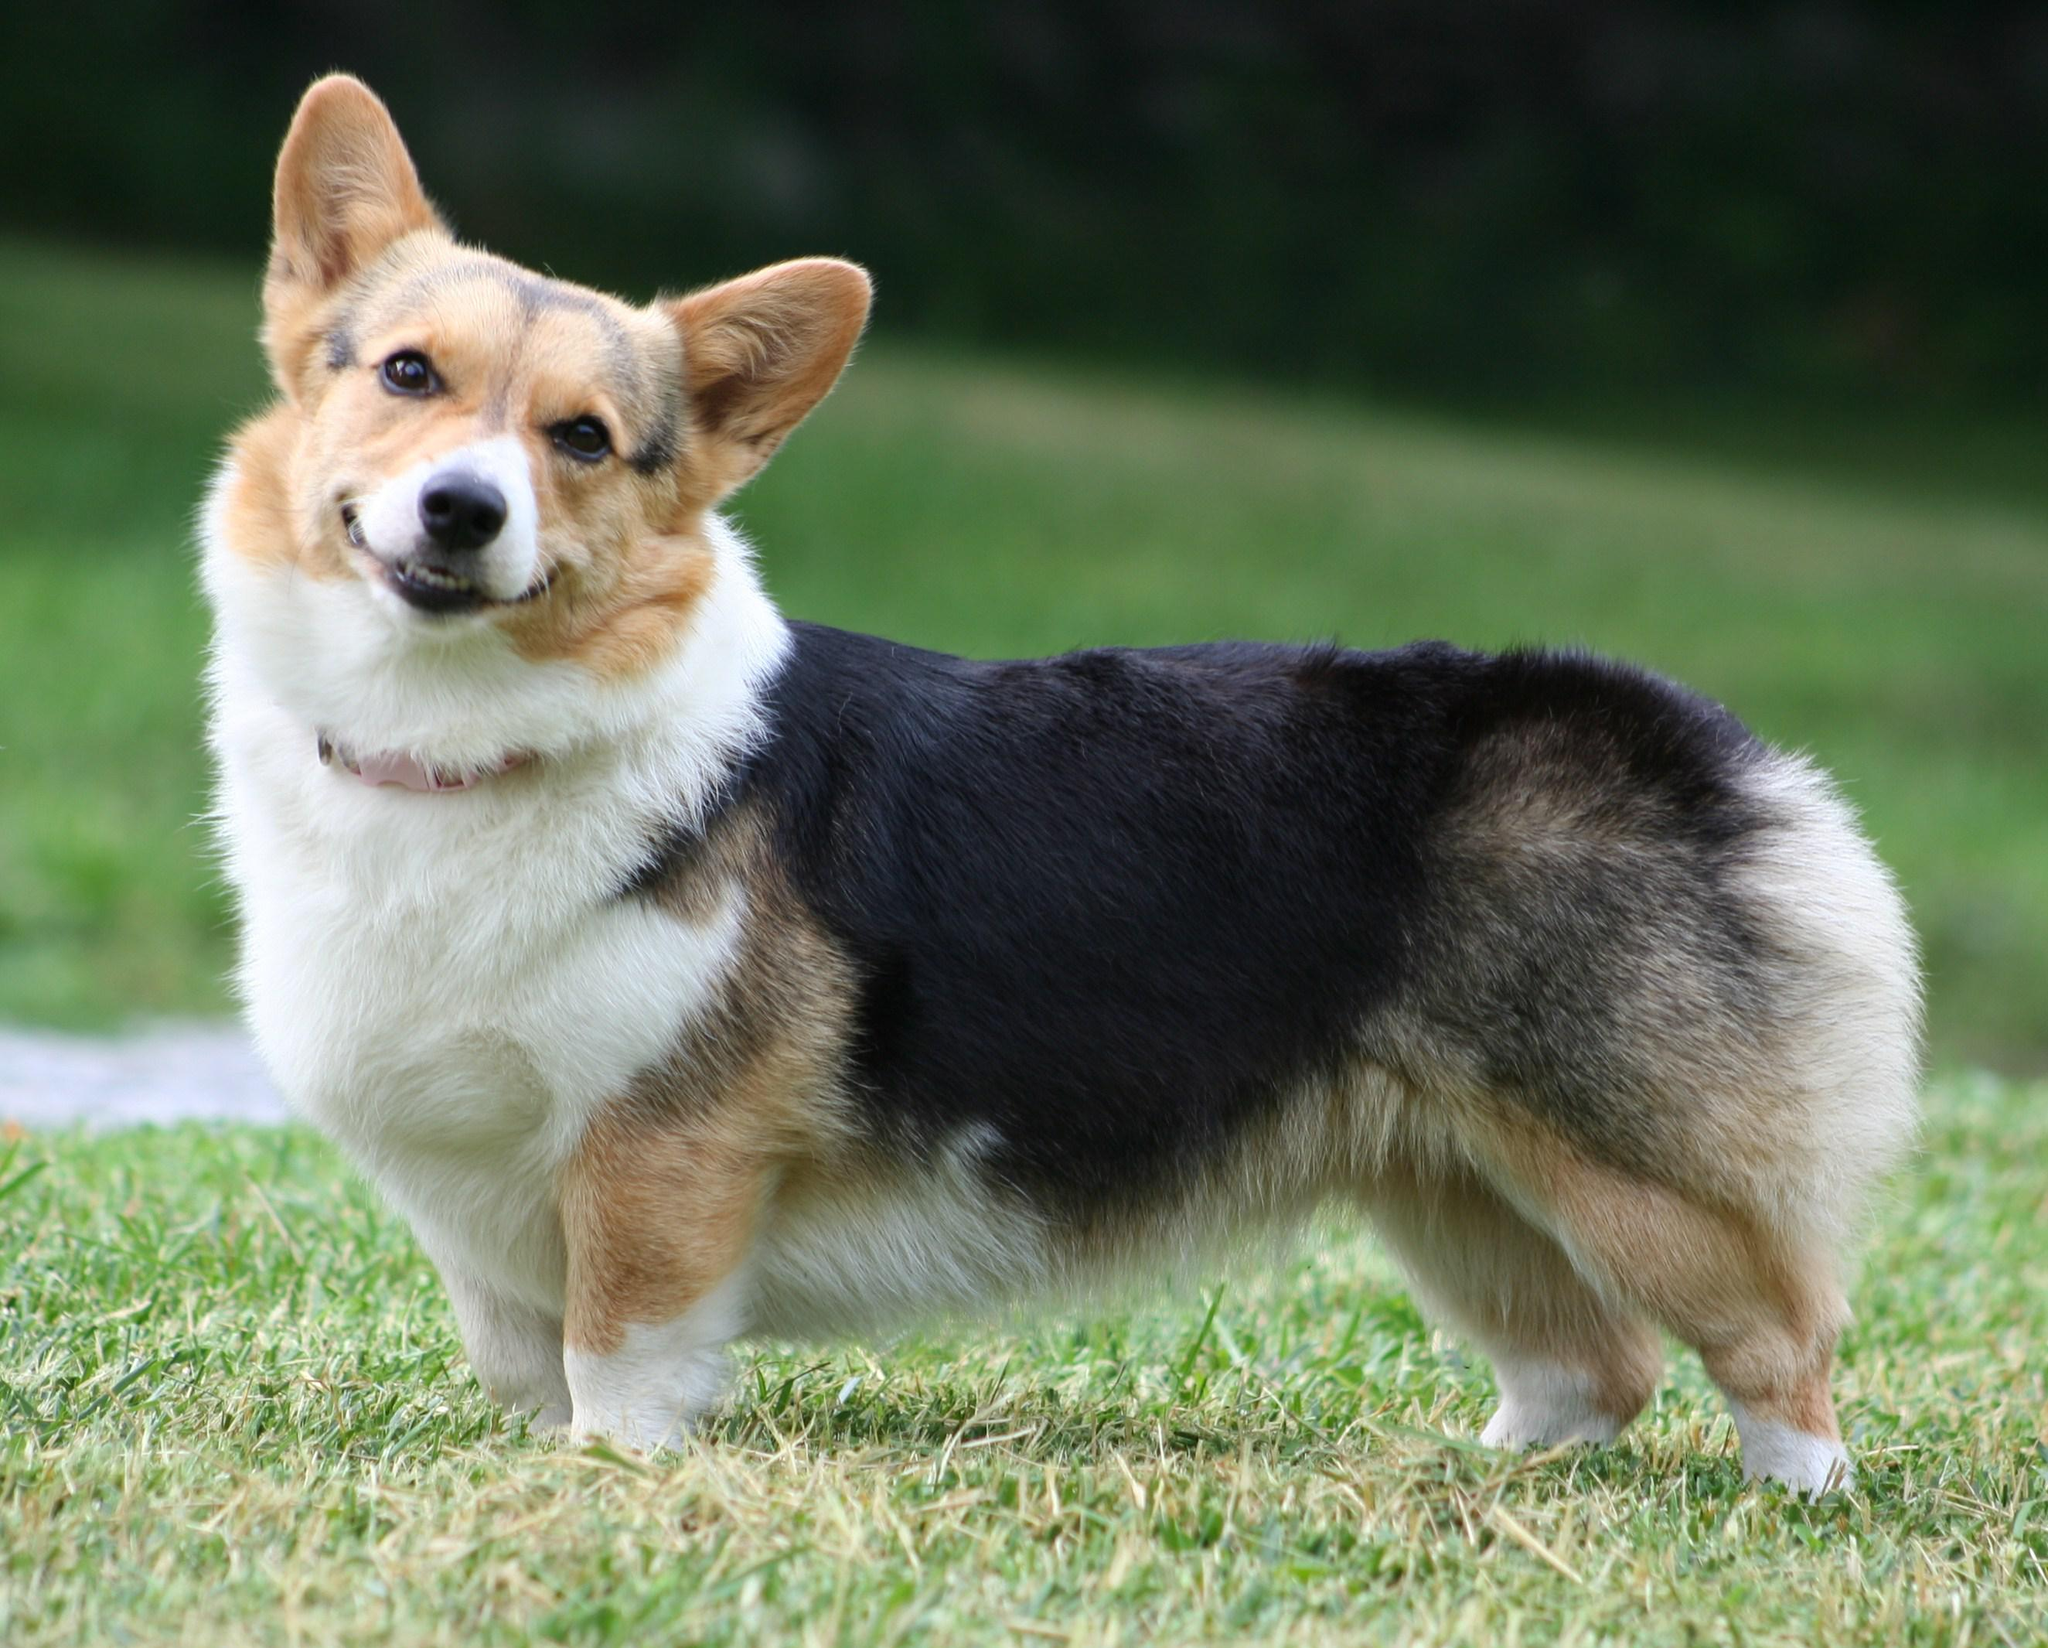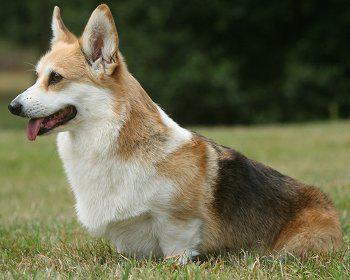The first image is the image on the left, the second image is the image on the right. Evaluate the accuracy of this statement regarding the images: "The entire dog is visible in the image on the left.". Is it true? Answer yes or no. Yes. 